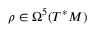Convert formula to latex. <formula><loc_0><loc_0><loc_500><loc_500>\rho \in \Omega ^ { 5 } ( T ^ { * } M )</formula> 